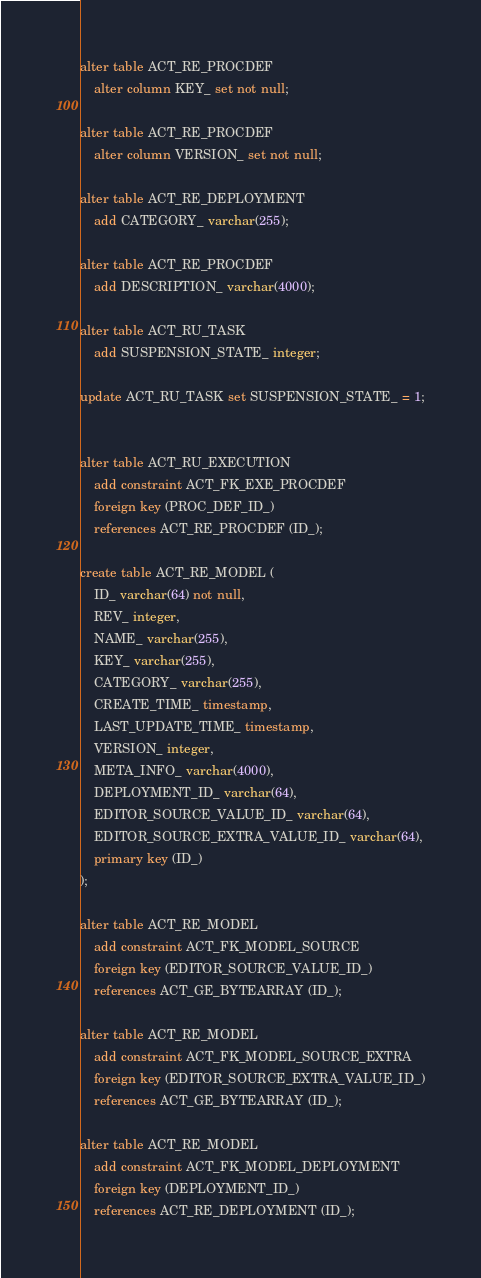Convert code to text. <code><loc_0><loc_0><loc_500><loc_500><_SQL_>alter table ACT_RE_PROCDEF
    alter column KEY_ set not null;

alter table ACT_RE_PROCDEF
    alter column VERSION_ set not null;

alter table ACT_RE_DEPLOYMENT
    add CATEGORY_ varchar(255);

alter table ACT_RE_PROCDEF
    add DESCRIPTION_ varchar(4000);

alter table ACT_RU_TASK
    add SUSPENSION_STATE_ integer;

update ACT_RU_TASK set SUSPENSION_STATE_ = 1;


alter table ACT_RU_EXECUTION
    add constraint ACT_FK_EXE_PROCDEF
    foreign key (PROC_DEF_ID_)
    references ACT_RE_PROCDEF (ID_);

create table ACT_RE_MODEL (
    ID_ varchar(64) not null,
    REV_ integer,
    NAME_ varchar(255),
    KEY_ varchar(255),
    CATEGORY_ varchar(255),
    CREATE_TIME_ timestamp,
    LAST_UPDATE_TIME_ timestamp,
    VERSION_ integer,
    META_INFO_ varchar(4000),
    DEPLOYMENT_ID_ varchar(64),
    EDITOR_SOURCE_VALUE_ID_ varchar(64),
    EDITOR_SOURCE_EXTRA_VALUE_ID_ varchar(64),
    primary key (ID_)
);

alter table ACT_RE_MODEL
    add constraint ACT_FK_MODEL_SOURCE
    foreign key (EDITOR_SOURCE_VALUE_ID_)
    references ACT_GE_BYTEARRAY (ID_);

alter table ACT_RE_MODEL
    add constraint ACT_FK_MODEL_SOURCE_EXTRA
    foreign key (EDITOR_SOURCE_EXTRA_VALUE_ID_)
    references ACT_GE_BYTEARRAY (ID_);

alter table ACT_RE_MODEL
    add constraint ACT_FK_MODEL_DEPLOYMENT
    foreign key (DEPLOYMENT_ID_)
    references ACT_RE_DEPLOYMENT (ID_);
</code> 